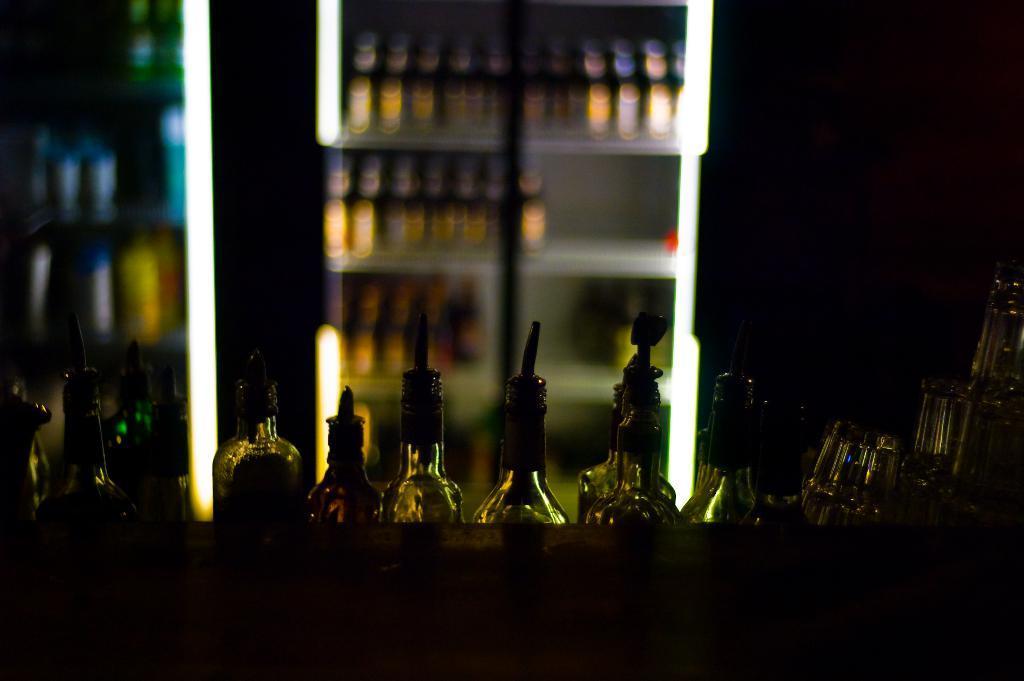Can you describe this image briefly? In this image I can see number of bottles. 